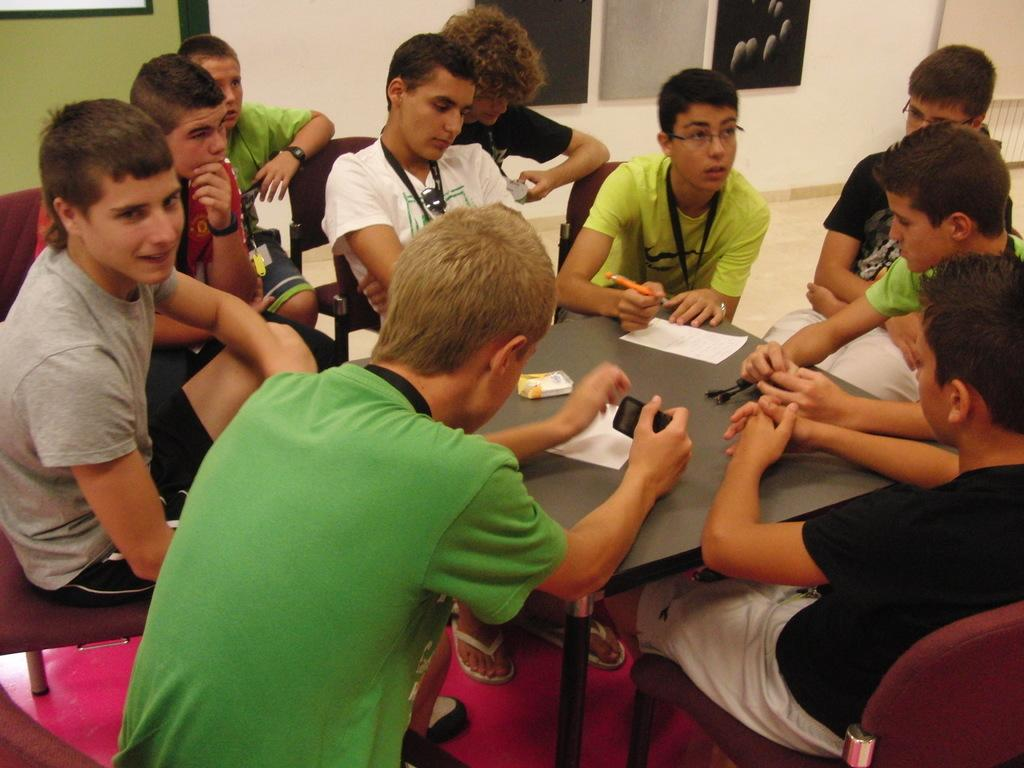How many people are in the image? There is a group of persons in the image, but the exact number is not specified. What are the persons doing in the image? The persons are sitting around a table. What objects can be seen on the table? There are papers on the table. What is visible in the background of the image? There is a wall visible in the image. What type of bucket can be seen floating in the water near the persons? There is no bucket or water present in the image; it features a group of persons sitting around a table with papers. 